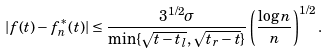<formula> <loc_0><loc_0><loc_500><loc_500>| f ( t ) - f _ { n } ^ { * } ( t ) | \leq \frac { 3 ^ { 1 / 2 } \sigma } { \min \{ \sqrt { t - t _ { l } } , \sqrt { t _ { r } - t } \} } \left ( \frac { \log n } { n } \right ) ^ { 1 / 2 } .</formula> 